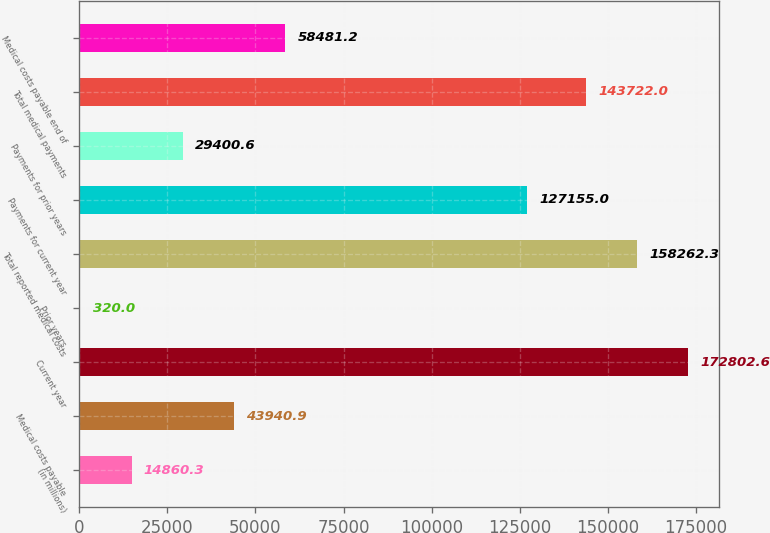Convert chart. <chart><loc_0><loc_0><loc_500><loc_500><bar_chart><fcel>(in millions)<fcel>Medical costs payable<fcel>Current year<fcel>Prior years<fcel>Total reported medical costs<fcel>Payments for current year<fcel>Payments for prior years<fcel>Total medical payments<fcel>Medical costs payable end of<nl><fcel>14860.3<fcel>43940.9<fcel>172803<fcel>320<fcel>158262<fcel>127155<fcel>29400.6<fcel>143722<fcel>58481.2<nl></chart> 